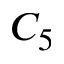Convert formula to latex. <formula><loc_0><loc_0><loc_500><loc_500>C _ { 5 }</formula> 